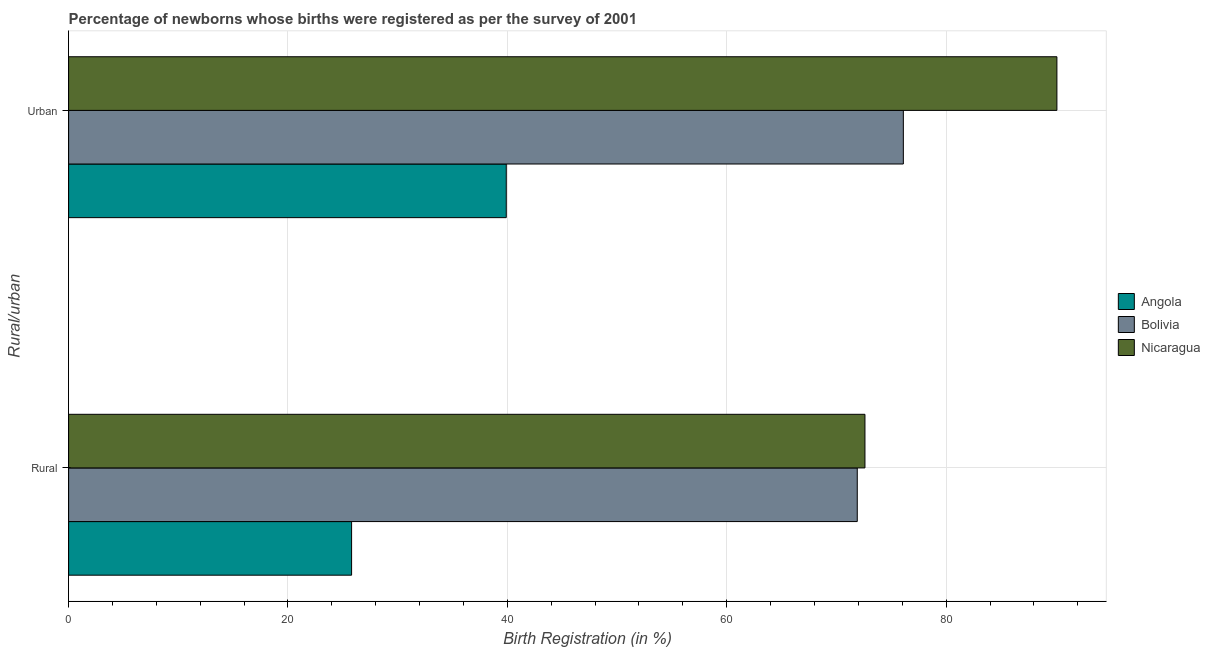How many groups of bars are there?
Offer a terse response. 2. Are the number of bars on each tick of the Y-axis equal?
Your answer should be compact. Yes. How many bars are there on the 1st tick from the top?
Your response must be concise. 3. How many bars are there on the 1st tick from the bottom?
Keep it short and to the point. 3. What is the label of the 2nd group of bars from the top?
Provide a short and direct response. Rural. What is the urban birth registration in Nicaragua?
Ensure brevity in your answer.  90.1. Across all countries, what is the maximum urban birth registration?
Provide a short and direct response. 90.1. Across all countries, what is the minimum rural birth registration?
Provide a short and direct response. 25.8. In which country was the urban birth registration maximum?
Make the answer very short. Nicaragua. In which country was the urban birth registration minimum?
Provide a short and direct response. Angola. What is the total rural birth registration in the graph?
Keep it short and to the point. 170.3. What is the difference between the urban birth registration in Nicaragua and that in Angola?
Make the answer very short. 50.2. What is the difference between the rural birth registration in Nicaragua and the urban birth registration in Angola?
Provide a succinct answer. 32.7. What is the average rural birth registration per country?
Your answer should be very brief. 56.77. What is the difference between the urban birth registration and rural birth registration in Angola?
Provide a succinct answer. 14.1. In how many countries, is the urban birth registration greater than 32 %?
Your response must be concise. 3. What is the ratio of the rural birth registration in Nicaragua to that in Angola?
Give a very brief answer. 2.81. Is the urban birth registration in Angola less than that in Bolivia?
Your response must be concise. Yes. In how many countries, is the urban birth registration greater than the average urban birth registration taken over all countries?
Your answer should be compact. 2. What does the 3rd bar from the top in Rural represents?
Ensure brevity in your answer.  Angola. What does the 2nd bar from the bottom in Rural represents?
Provide a succinct answer. Bolivia. Are all the bars in the graph horizontal?
Provide a succinct answer. Yes. Are the values on the major ticks of X-axis written in scientific E-notation?
Keep it short and to the point. No. Does the graph contain grids?
Give a very brief answer. Yes. Where does the legend appear in the graph?
Offer a terse response. Center right. How many legend labels are there?
Your answer should be compact. 3. What is the title of the graph?
Provide a succinct answer. Percentage of newborns whose births were registered as per the survey of 2001. Does "Syrian Arab Republic" appear as one of the legend labels in the graph?
Provide a succinct answer. No. What is the label or title of the X-axis?
Give a very brief answer. Birth Registration (in %). What is the label or title of the Y-axis?
Give a very brief answer. Rural/urban. What is the Birth Registration (in %) of Angola in Rural?
Offer a very short reply. 25.8. What is the Birth Registration (in %) of Bolivia in Rural?
Offer a very short reply. 71.9. What is the Birth Registration (in %) in Nicaragua in Rural?
Your answer should be very brief. 72.6. What is the Birth Registration (in %) in Angola in Urban?
Your answer should be very brief. 39.9. What is the Birth Registration (in %) of Bolivia in Urban?
Provide a short and direct response. 76.1. What is the Birth Registration (in %) in Nicaragua in Urban?
Your answer should be compact. 90.1. Across all Rural/urban, what is the maximum Birth Registration (in %) in Angola?
Offer a very short reply. 39.9. Across all Rural/urban, what is the maximum Birth Registration (in %) in Bolivia?
Keep it short and to the point. 76.1. Across all Rural/urban, what is the maximum Birth Registration (in %) in Nicaragua?
Your answer should be very brief. 90.1. Across all Rural/urban, what is the minimum Birth Registration (in %) of Angola?
Ensure brevity in your answer.  25.8. Across all Rural/urban, what is the minimum Birth Registration (in %) of Bolivia?
Your response must be concise. 71.9. Across all Rural/urban, what is the minimum Birth Registration (in %) of Nicaragua?
Make the answer very short. 72.6. What is the total Birth Registration (in %) of Angola in the graph?
Keep it short and to the point. 65.7. What is the total Birth Registration (in %) in Bolivia in the graph?
Provide a succinct answer. 148. What is the total Birth Registration (in %) in Nicaragua in the graph?
Provide a succinct answer. 162.7. What is the difference between the Birth Registration (in %) in Angola in Rural and that in Urban?
Keep it short and to the point. -14.1. What is the difference between the Birth Registration (in %) of Nicaragua in Rural and that in Urban?
Make the answer very short. -17.5. What is the difference between the Birth Registration (in %) of Angola in Rural and the Birth Registration (in %) of Bolivia in Urban?
Offer a very short reply. -50.3. What is the difference between the Birth Registration (in %) of Angola in Rural and the Birth Registration (in %) of Nicaragua in Urban?
Provide a short and direct response. -64.3. What is the difference between the Birth Registration (in %) in Bolivia in Rural and the Birth Registration (in %) in Nicaragua in Urban?
Give a very brief answer. -18.2. What is the average Birth Registration (in %) of Angola per Rural/urban?
Offer a terse response. 32.85. What is the average Birth Registration (in %) in Bolivia per Rural/urban?
Provide a short and direct response. 74. What is the average Birth Registration (in %) in Nicaragua per Rural/urban?
Your response must be concise. 81.35. What is the difference between the Birth Registration (in %) of Angola and Birth Registration (in %) of Bolivia in Rural?
Provide a succinct answer. -46.1. What is the difference between the Birth Registration (in %) of Angola and Birth Registration (in %) of Nicaragua in Rural?
Your response must be concise. -46.8. What is the difference between the Birth Registration (in %) in Bolivia and Birth Registration (in %) in Nicaragua in Rural?
Offer a terse response. -0.7. What is the difference between the Birth Registration (in %) in Angola and Birth Registration (in %) in Bolivia in Urban?
Ensure brevity in your answer.  -36.2. What is the difference between the Birth Registration (in %) of Angola and Birth Registration (in %) of Nicaragua in Urban?
Give a very brief answer. -50.2. What is the difference between the Birth Registration (in %) of Bolivia and Birth Registration (in %) of Nicaragua in Urban?
Ensure brevity in your answer.  -14. What is the ratio of the Birth Registration (in %) of Angola in Rural to that in Urban?
Offer a terse response. 0.65. What is the ratio of the Birth Registration (in %) of Bolivia in Rural to that in Urban?
Your answer should be compact. 0.94. What is the ratio of the Birth Registration (in %) of Nicaragua in Rural to that in Urban?
Your response must be concise. 0.81. What is the difference between the highest and the second highest Birth Registration (in %) in Angola?
Ensure brevity in your answer.  14.1. What is the difference between the highest and the second highest Birth Registration (in %) of Bolivia?
Your answer should be compact. 4.2. What is the difference between the highest and the second highest Birth Registration (in %) in Nicaragua?
Provide a short and direct response. 17.5. What is the difference between the highest and the lowest Birth Registration (in %) in Nicaragua?
Offer a terse response. 17.5. 